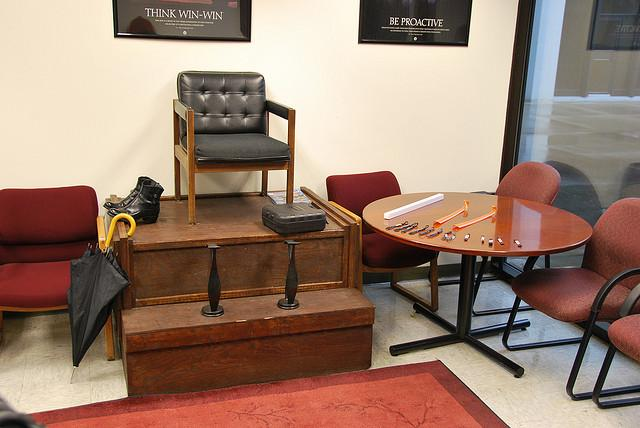What activity goes on in the chair on the platform? Please explain your reasoning. shoe shining. The activity is shoe shining. 